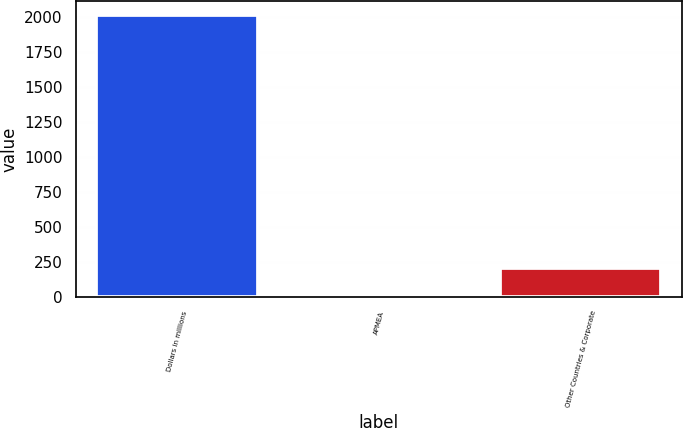<chart> <loc_0><loc_0><loc_500><loc_500><bar_chart><fcel>Dollars in millions<fcel>APMEA<fcel>Other Countries & Corporate<nl><fcel>2008<fcel>8<fcel>208<nl></chart> 